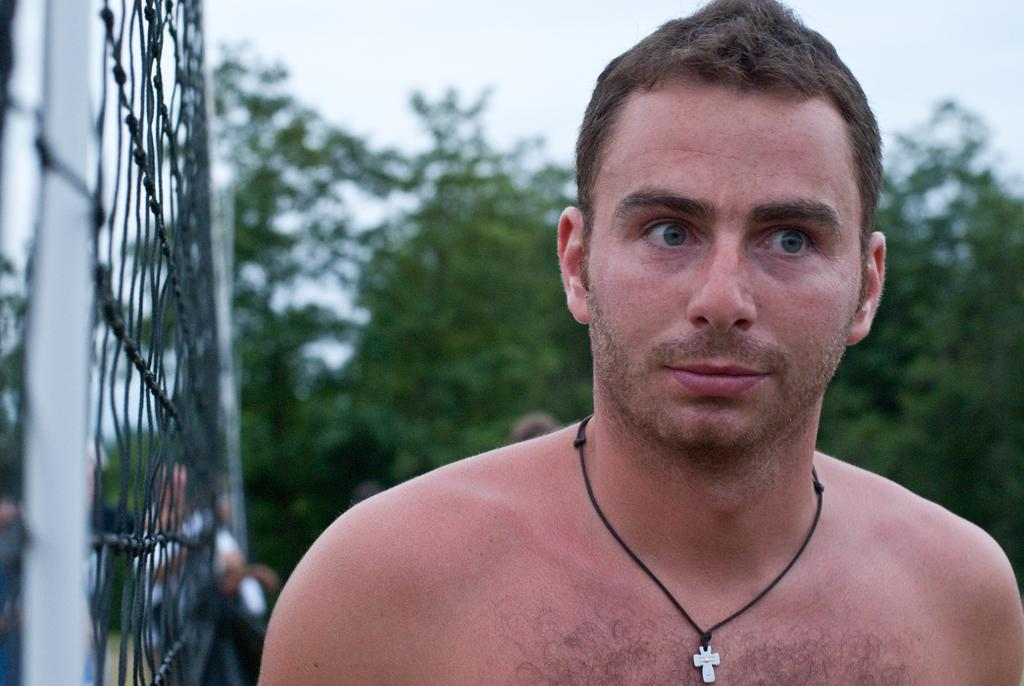Who is present in the image? There is a man and other people in the image. What is located on the left side of the image? There is a net on the left side of the image. What can be seen in the background of the image? There are trees and sky visible in the background of the image. What type of needle can be seen in the image? There is no needle present in the image. How does the harbor look in the image? There is no harbor present in the image. 